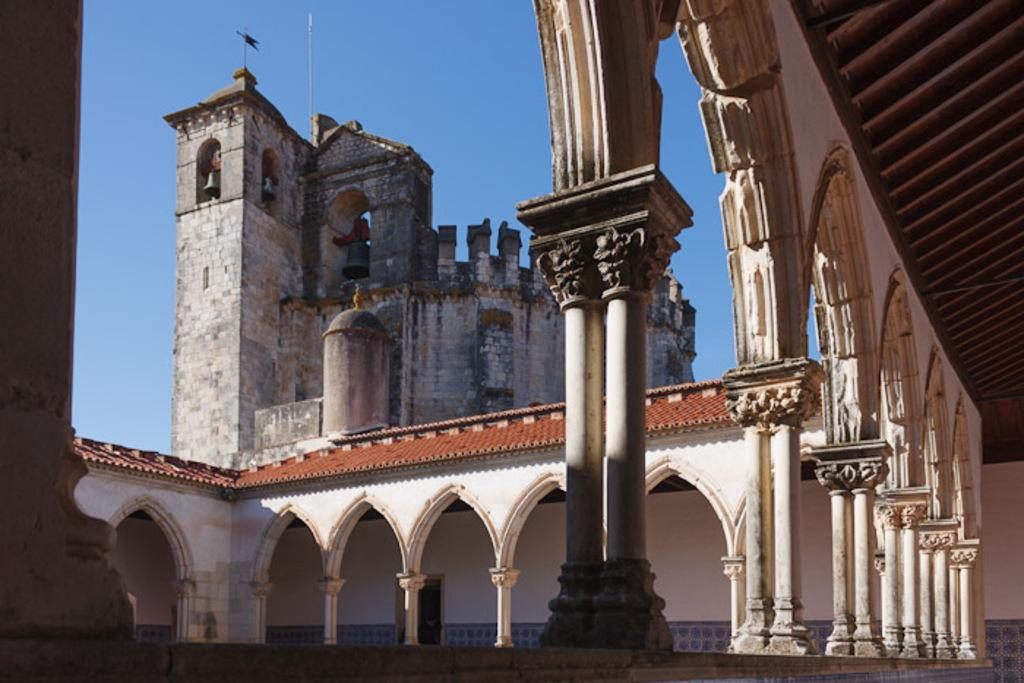What is the main subject of the image? The main subject of the image is a view of a building. What can be seen in the background of the image? The sky is visible at the top of the image. Are there any other objects or structures in the image besides the building? Yes, there is a pole in the image. What type of tax is being discussed in the image? There is no discussion of tax in the image; it features a view of a building, the sky, and a pole. What type of agreement is being signed in the image? There is no agreement being signed in the image; it features a view of a building, the sky, and a pole. 